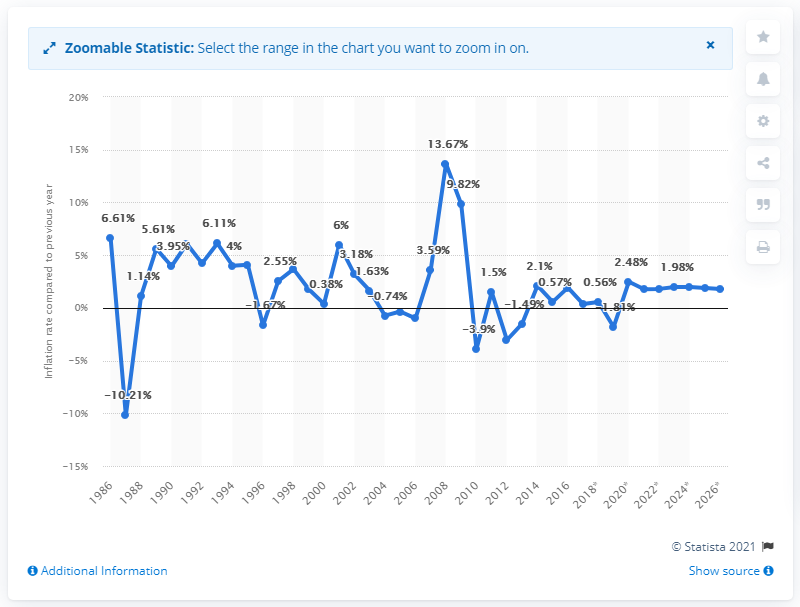Mention a couple of crucial points in this snapshot. In 2017, the inflation rate in Kiribati was 0.36%. 